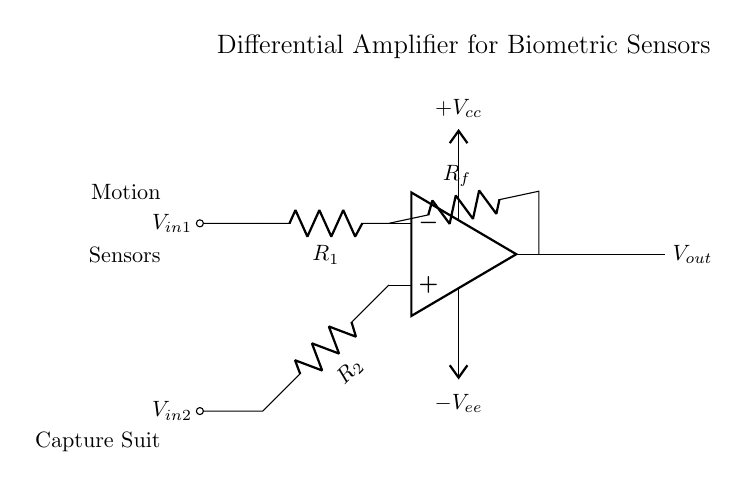What type of amplifier is illustrated? The diagram depicts a differential amplifier, which is specifically designed to amplify the difference between two input voltages. The presence of two input resistors and the op-amp configuration signifies this type.
Answer: Differential amplifier What is the role of R_f in this circuit? R_f, the feedback resistor, is crucial in setting the gain of the amplifier. It connects the output back to the inverting input, helping to control the amplification level based on the resistor values involved.
Answer: Feedback resistor How many input voltages does this circuit accept? The circuit is configured to accept two input voltages, indicated by the nodes labeled V_in1 and V_in2 connected to the non-inverting and inverting terminals of the op-amp.
Answer: Two What do the labels +V_cc and -V_ee indicate? These labels refer to the power supply voltages for the op-amp. +V_cc is the positive supply voltage, while -V_ee is the negative supply voltage, necessary for the op-amp to operate correctly.
Answer: Power supply voltages What are the two types of sensors mentioned in the diagram? The diagram includes labels for "Motion" and "Capture Suit", highlighting the specific sensors involved in the configuration utilized for biometric sensing in the motion capture context.
Answer: Motion and Capture Suit How does this circuit handle differential signals? The differential amplifier configuration allows it to amplify the difference between the two input signals, V_in1 and V_in2, effectively rejecting any common-mode signals that might interfere with the captured data.
Answer: Rejects common-mode signals 